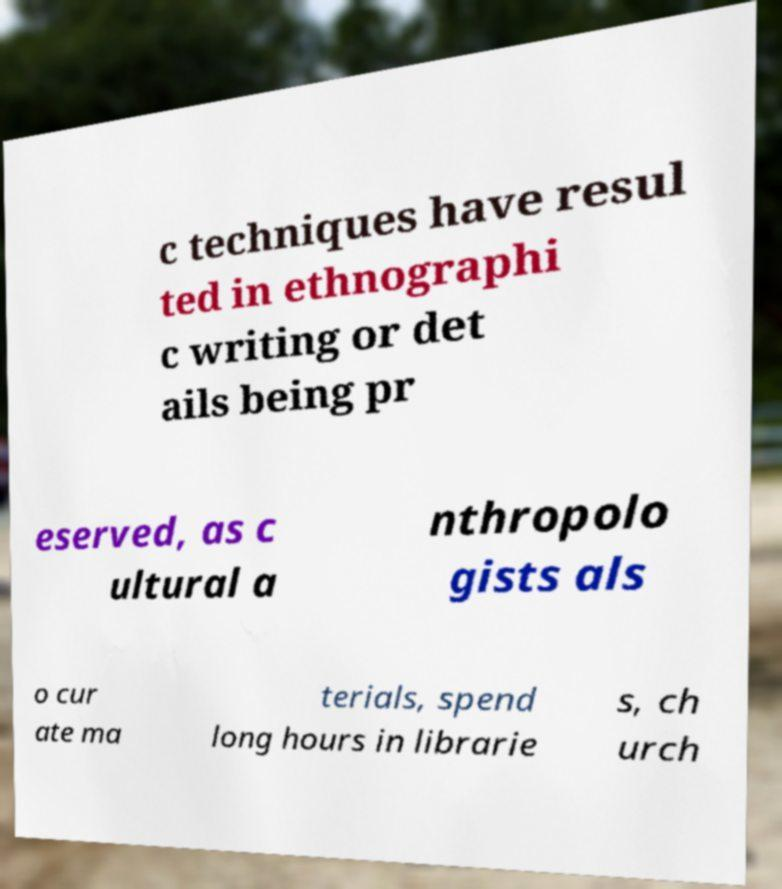There's text embedded in this image that I need extracted. Can you transcribe it verbatim? c techniques have resul ted in ethnographi c writing or det ails being pr eserved, as c ultural a nthropolo gists als o cur ate ma terials, spend long hours in librarie s, ch urch 